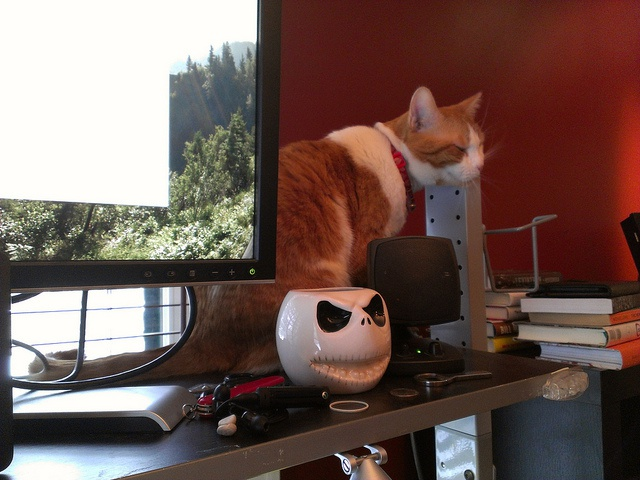Describe the objects in this image and their specific colors. I can see tv in white, black, gray, and darkgray tones, cat in white, maroon, brown, and salmon tones, cup in white, darkgray, brown, black, and gray tones, book in white, darkgray, black, and gray tones, and book in white, black, maroon, and brown tones in this image. 